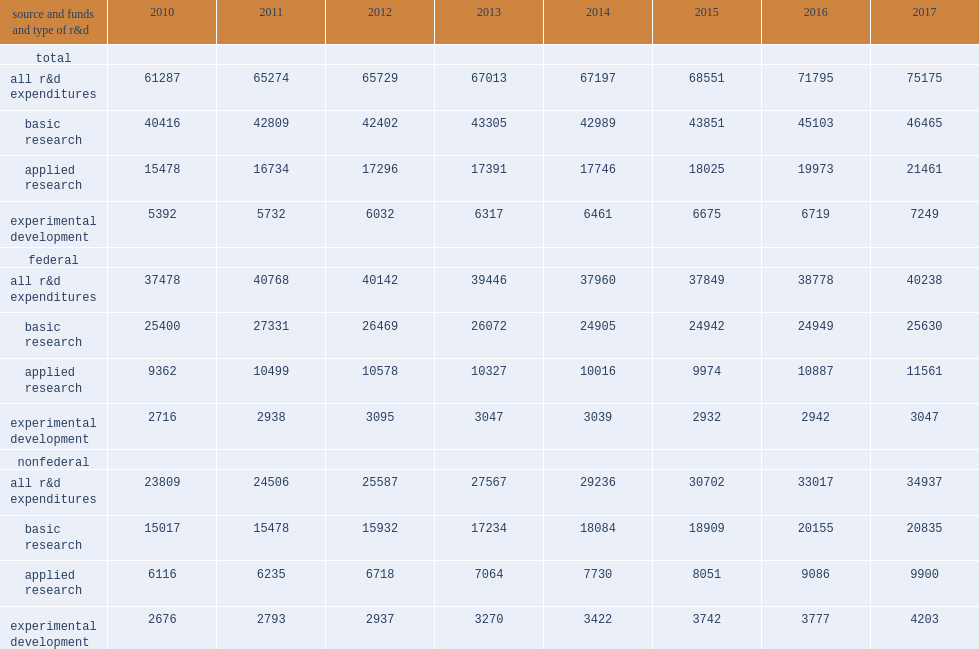How many million dollars spent on r&d in fy 2017? 75175.0. Of the $75.2 billion spent on r&d in fy 2017, how many percent was categorized as basic research? 0.618091. Of the $75.2 billion spent on r&d in fy 2017, how many percent was categorized as applied research? 0.285481. Of the $75.2 billion spent on r&d in fy 2017, how many percent was categorized as experimental development? 0.096428. What was the shares in fy 2010 for basic research? 0.659455. What was the shares in fy 2010 for applied research? 0.252549. What was the shares in fy 2010 for experimental development? 0.08798. 